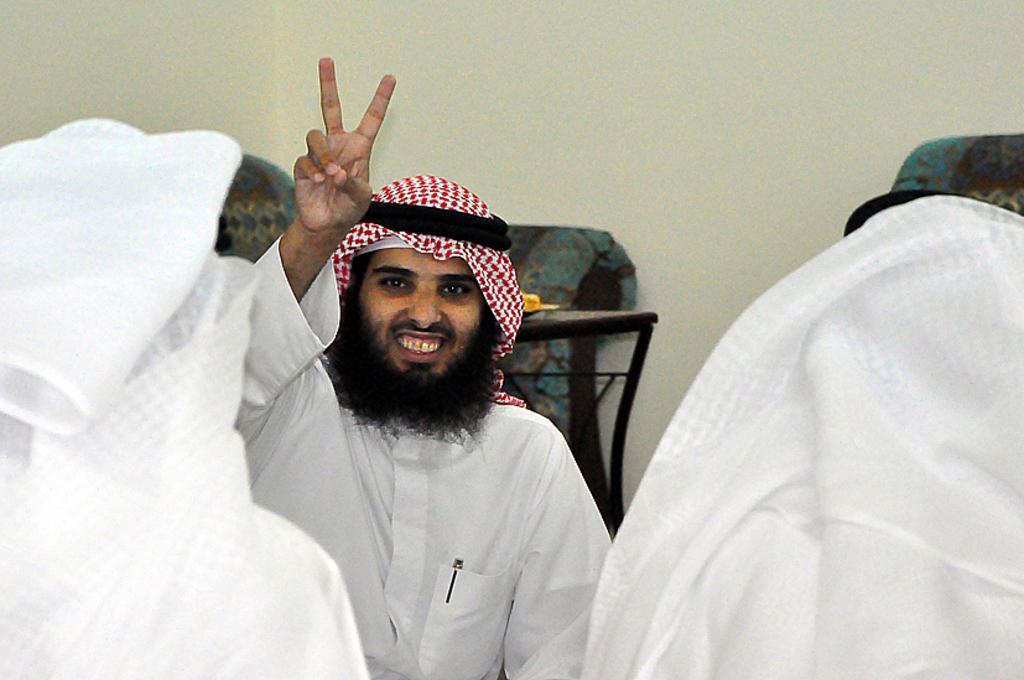Could you give a brief overview of what you see in this image? There are people and this man smiling. In the background we can see table and wall. 